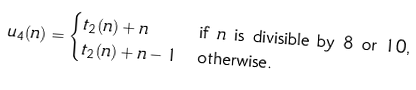Convert formula to latex. <formula><loc_0><loc_0><loc_500><loc_500>u _ { 4 } ( n ) & = \begin{cases} t _ { 2 } ( n ) + n & \text {if $n$ is divisible by $8$ or $10$,} \\ t _ { 2 } ( n ) + n - 1 & \text {otherwise.} \end{cases}</formula> 